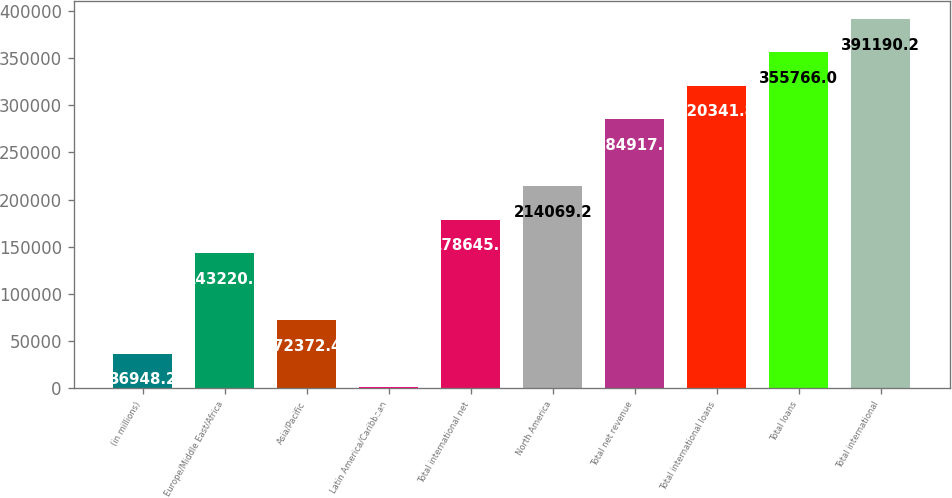<chart> <loc_0><loc_0><loc_500><loc_500><bar_chart><fcel>(in millions)<fcel>Europe/Middle East/Africa<fcel>Asia/Pacific<fcel>Latin America/Caribbean<fcel>Total international net<fcel>North America<fcel>Total net revenue<fcel>Total international loans<fcel>Total loans<fcel>Total international<nl><fcel>36948.2<fcel>143221<fcel>72372.4<fcel>1524<fcel>178645<fcel>214069<fcel>284918<fcel>320342<fcel>355766<fcel>391190<nl></chart> 